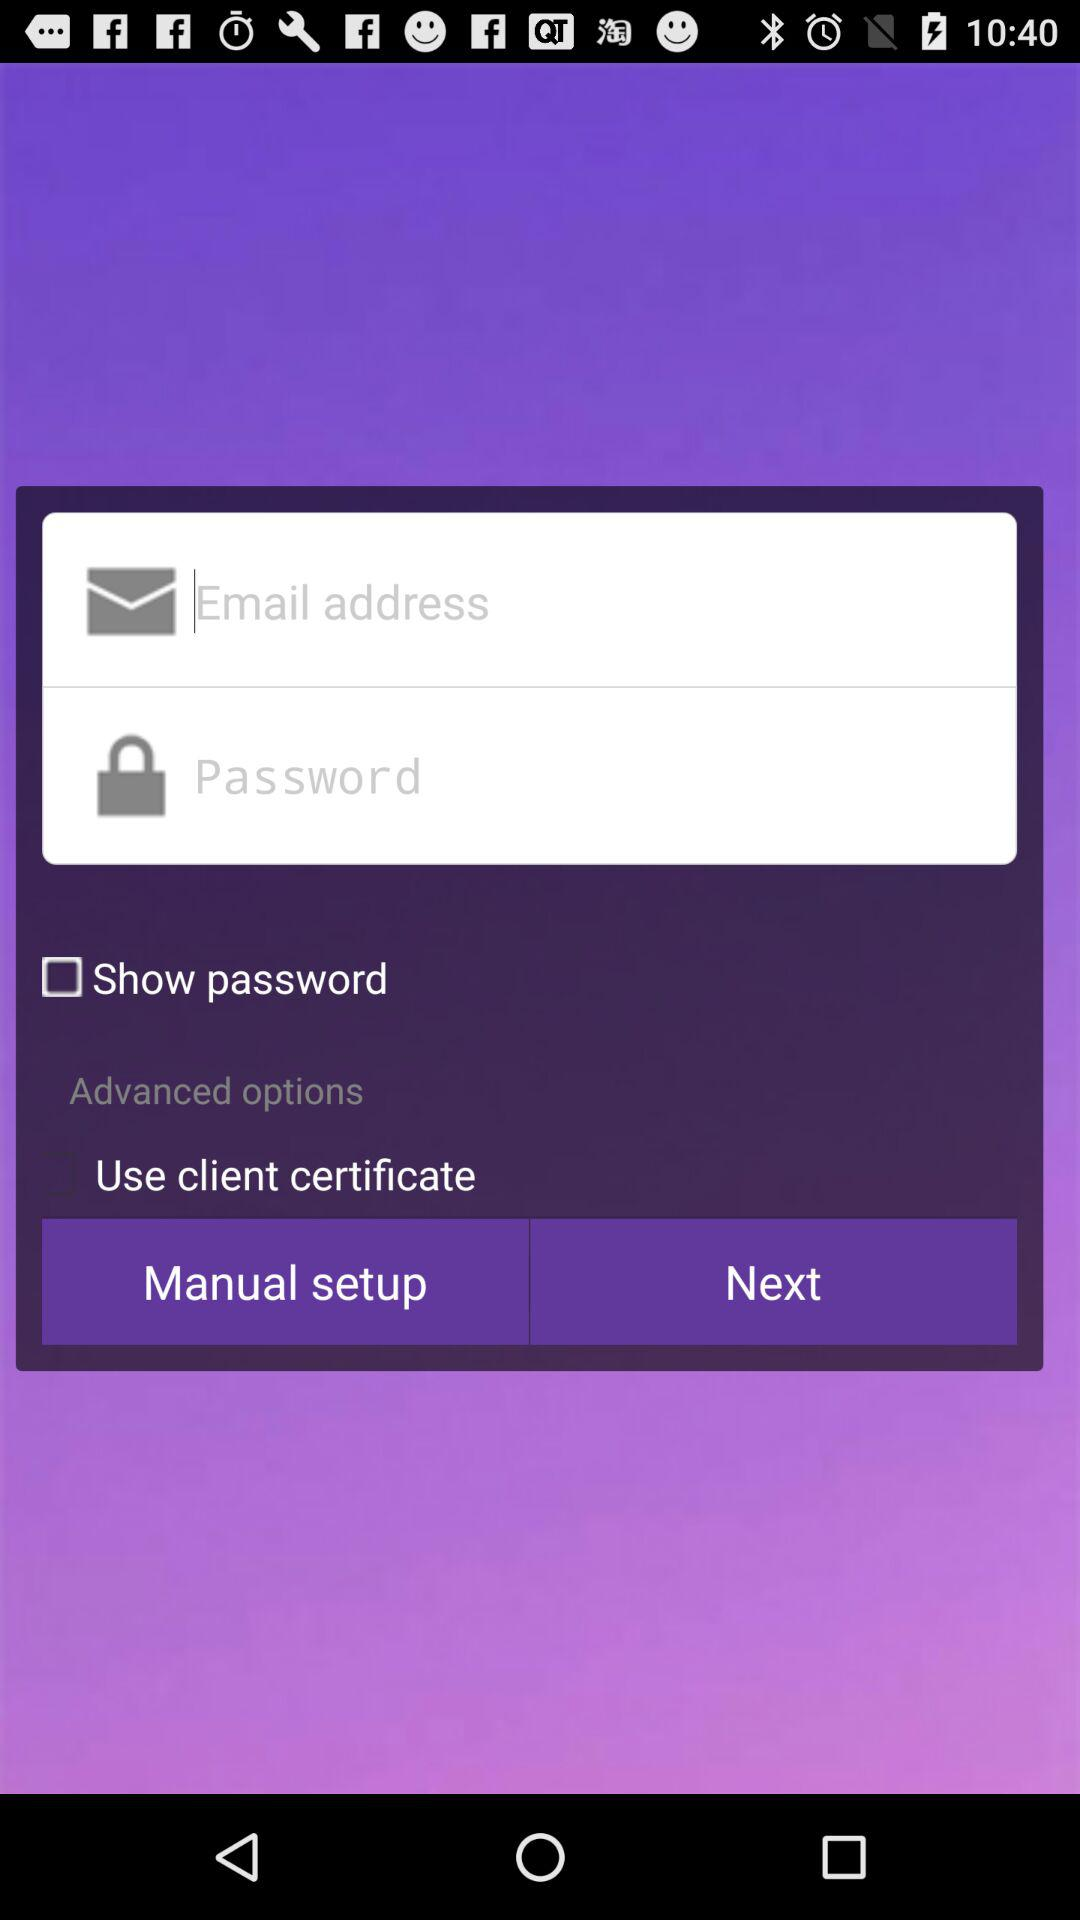What is the status of show password? The status is off. 